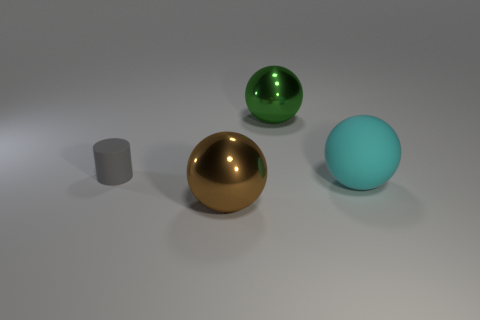Is there any other thing that is the same shape as the gray object?
Provide a succinct answer. No. Is the shape of the gray object the same as the object behind the gray rubber cylinder?
Your answer should be compact. No. There is another matte object that is the same shape as the big green object; what size is it?
Provide a succinct answer. Large. What number of other things are there of the same material as the brown thing
Your answer should be very brief. 1. What material is the gray object?
Provide a succinct answer. Rubber. There is a metallic ball that is in front of the gray cylinder; does it have the same color as the rubber object on the right side of the big green object?
Provide a succinct answer. No. Is the number of green shiny objects in front of the large brown sphere greater than the number of rubber cylinders?
Keep it short and to the point. No. What number of other objects are there of the same color as the cylinder?
Ensure brevity in your answer.  0. There is a brown object in front of the cyan sphere; is it the same size as the small rubber cylinder?
Make the answer very short. No. Is there a cyan rubber thing that has the same size as the brown sphere?
Offer a very short reply. Yes. 